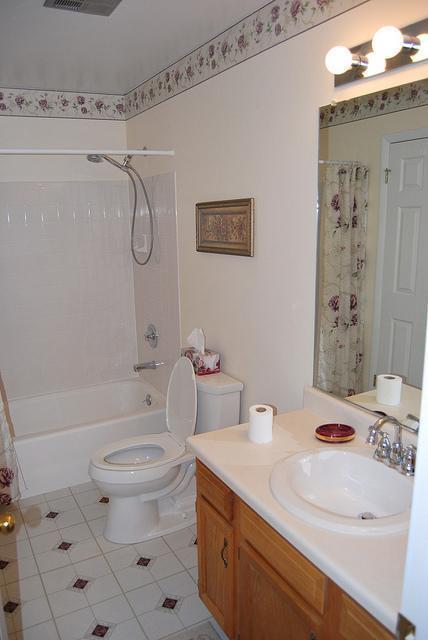How many diamond shapes are here?
Give a very brief answer. 10. How many women are standing in front of video game monitors?
Give a very brief answer. 0. 